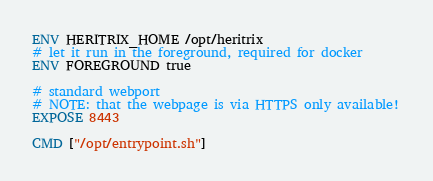Convert code to text. <code><loc_0><loc_0><loc_500><loc_500><_Dockerfile_>
ENV HERITRIX_HOME /opt/heritrix
# let it run in the foreground, required for docker
ENV FOREGROUND true

# standard webport
# NOTE: that the webpage is via HTTPS only available!
EXPOSE 8443

CMD ["/opt/entrypoint.sh"]
</code> 